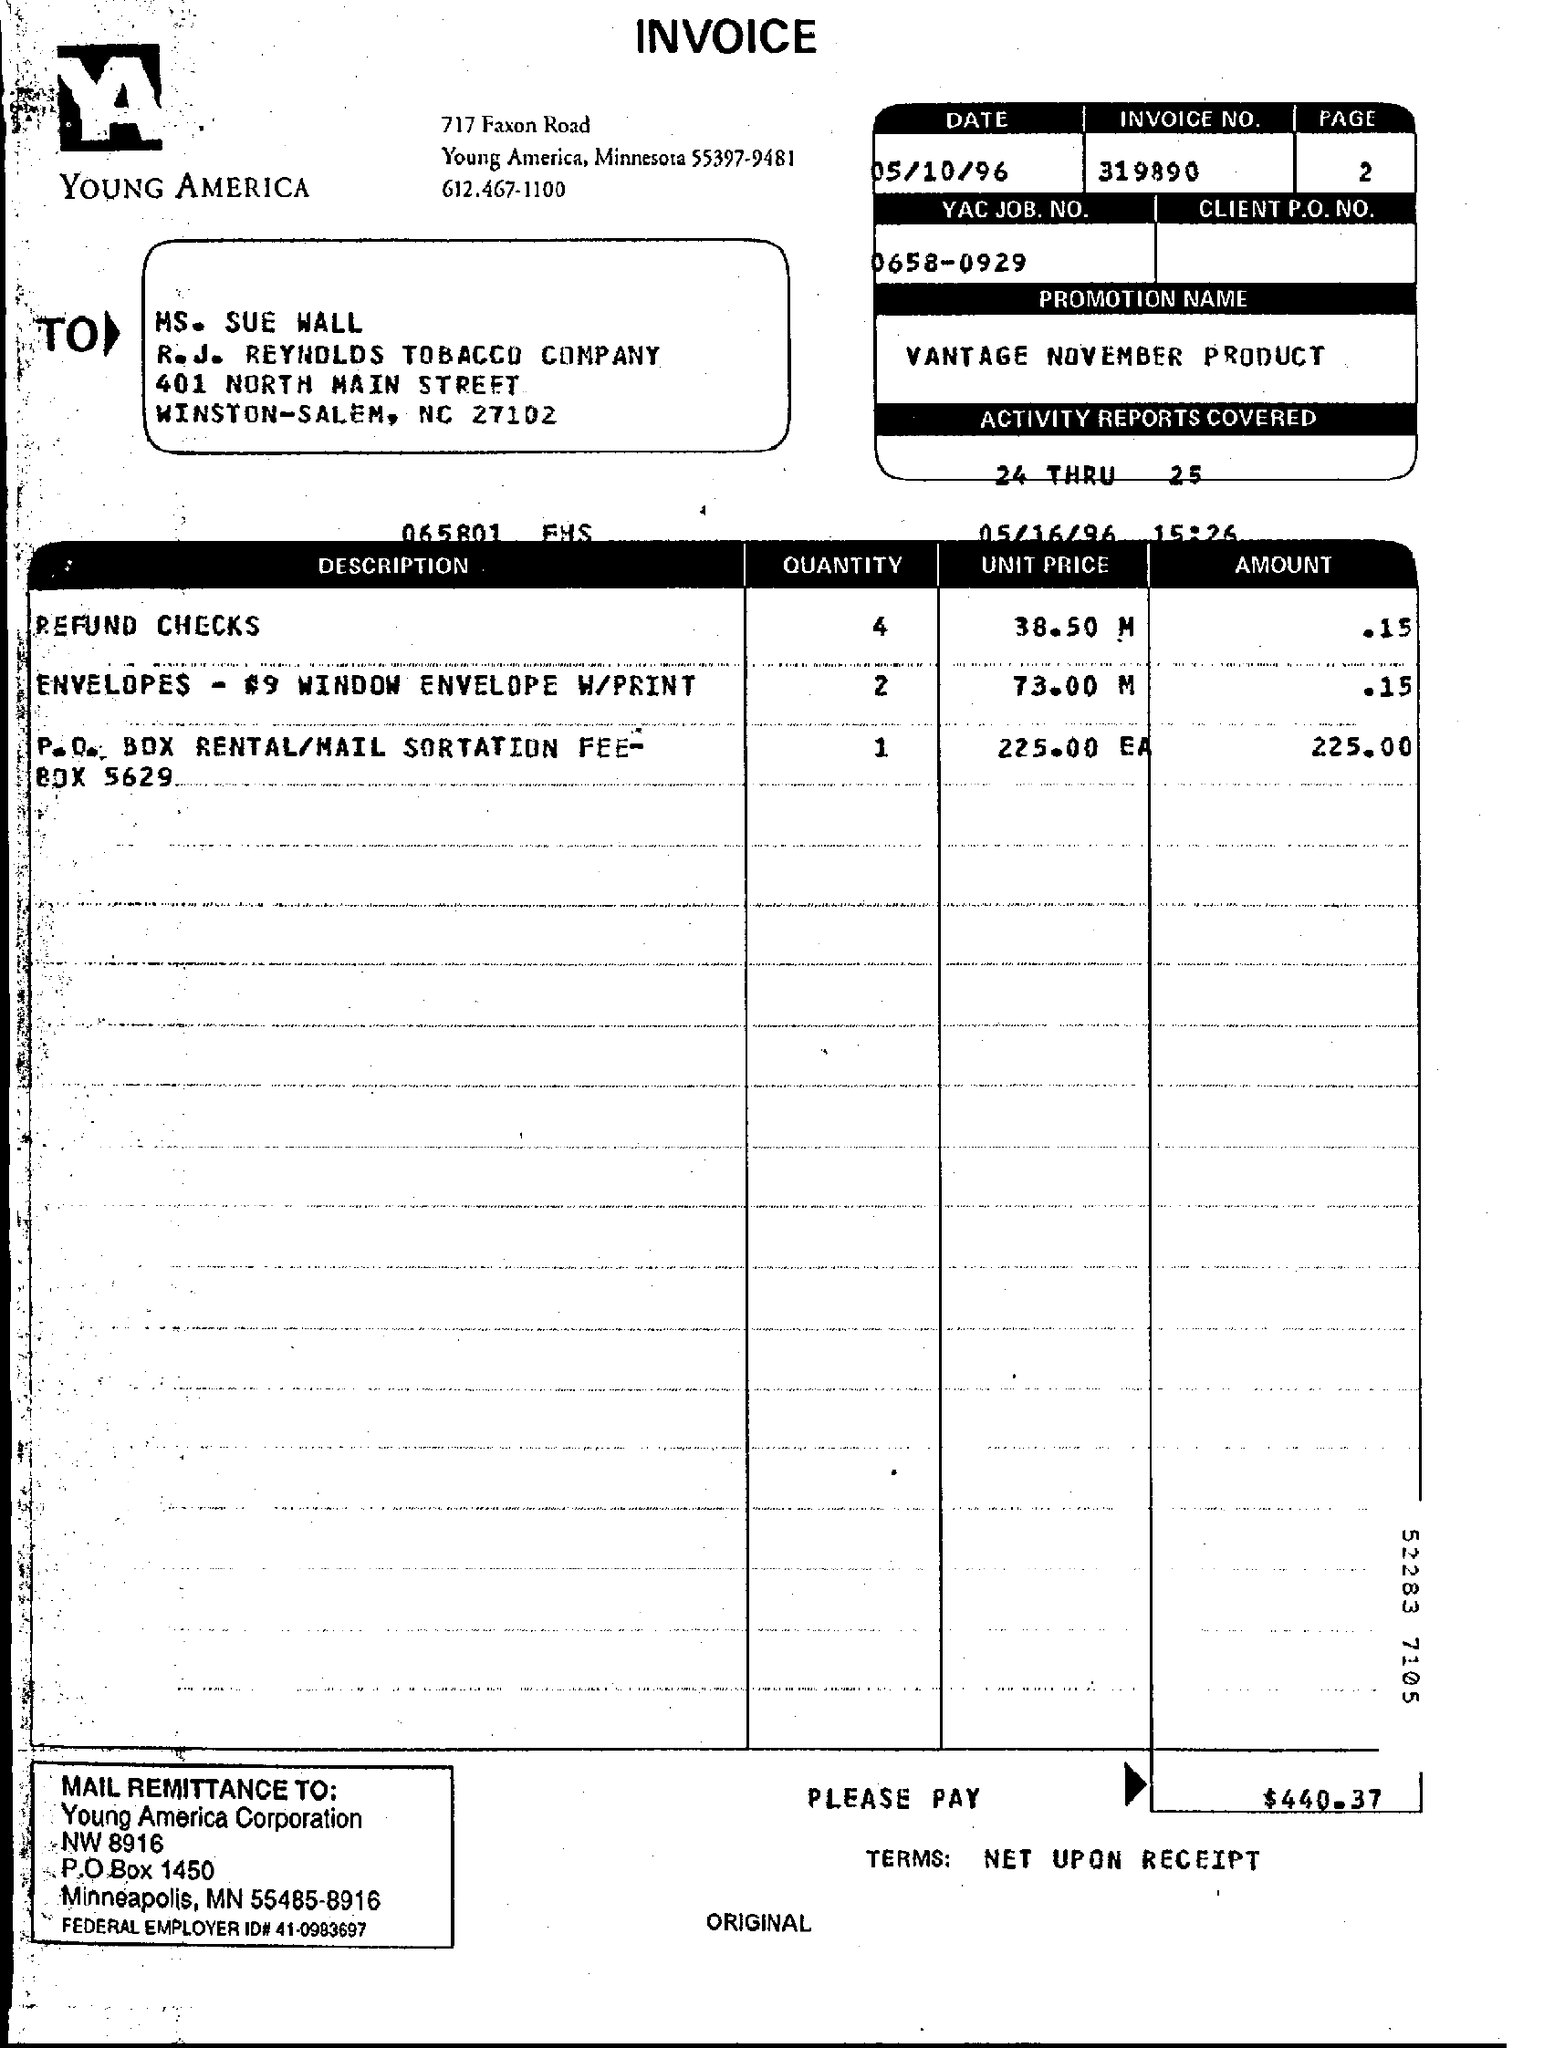Outline some significant characteristics in this image. The federal employer identification number for a certain entity is 41-0983697. The total amount that has to be paid is $440.37. The P.O. Box of Young America Corporation is located at 1450... YAC JOB. NO? 0658-0929" is a code or identification number. The page number mentioned is 2. 